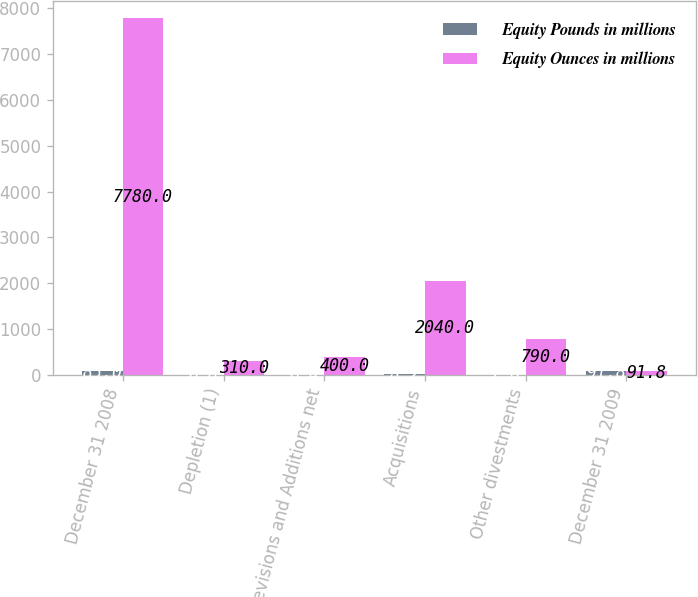<chart> <loc_0><loc_0><loc_500><loc_500><stacked_bar_chart><ecel><fcel>December 31 2008<fcel>Depletion (1)<fcel>Revisions and Additions net<fcel>Acquisitions<fcel>Other divestments<fcel>December 31 2009<nl><fcel>Equity Pounds in millions<fcel>85<fcel>6.8<fcel>6.4<fcel>8.2<fcel>1<fcel>91.8<nl><fcel>Equity Ounces in millions<fcel>7780<fcel>310<fcel>400<fcel>2040<fcel>790<fcel>91.8<nl></chart> 